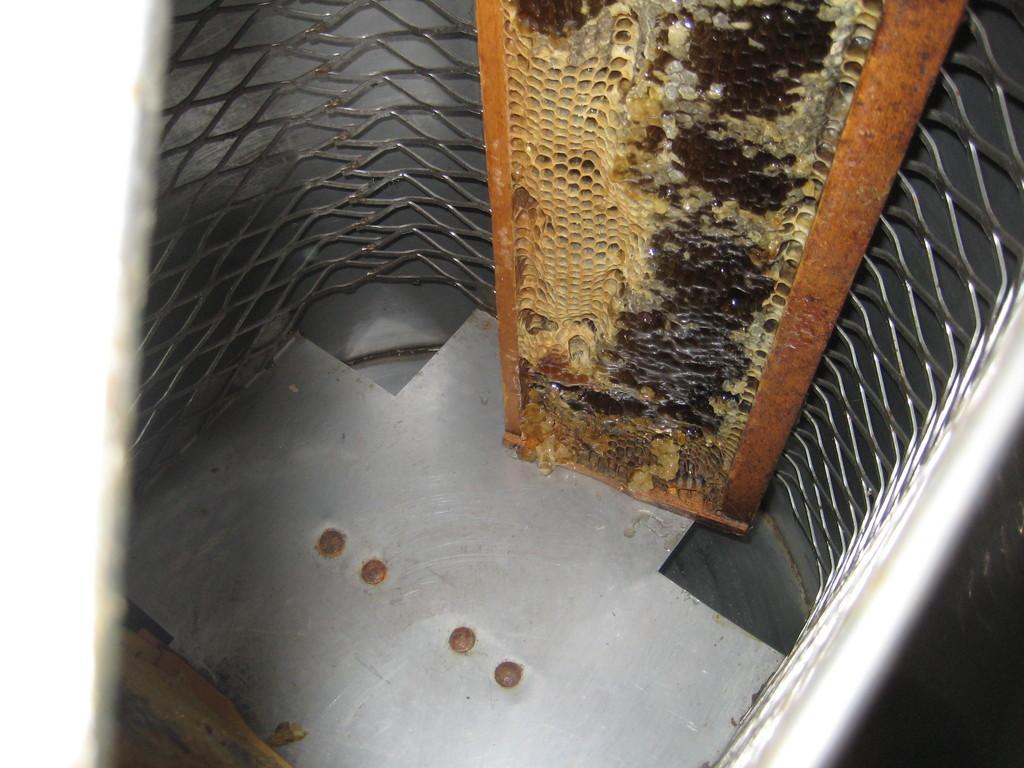Could you give a brief overview of what you see in this image? In this image we can see the honeycomb placed on the steel surface inside the metal fence. 